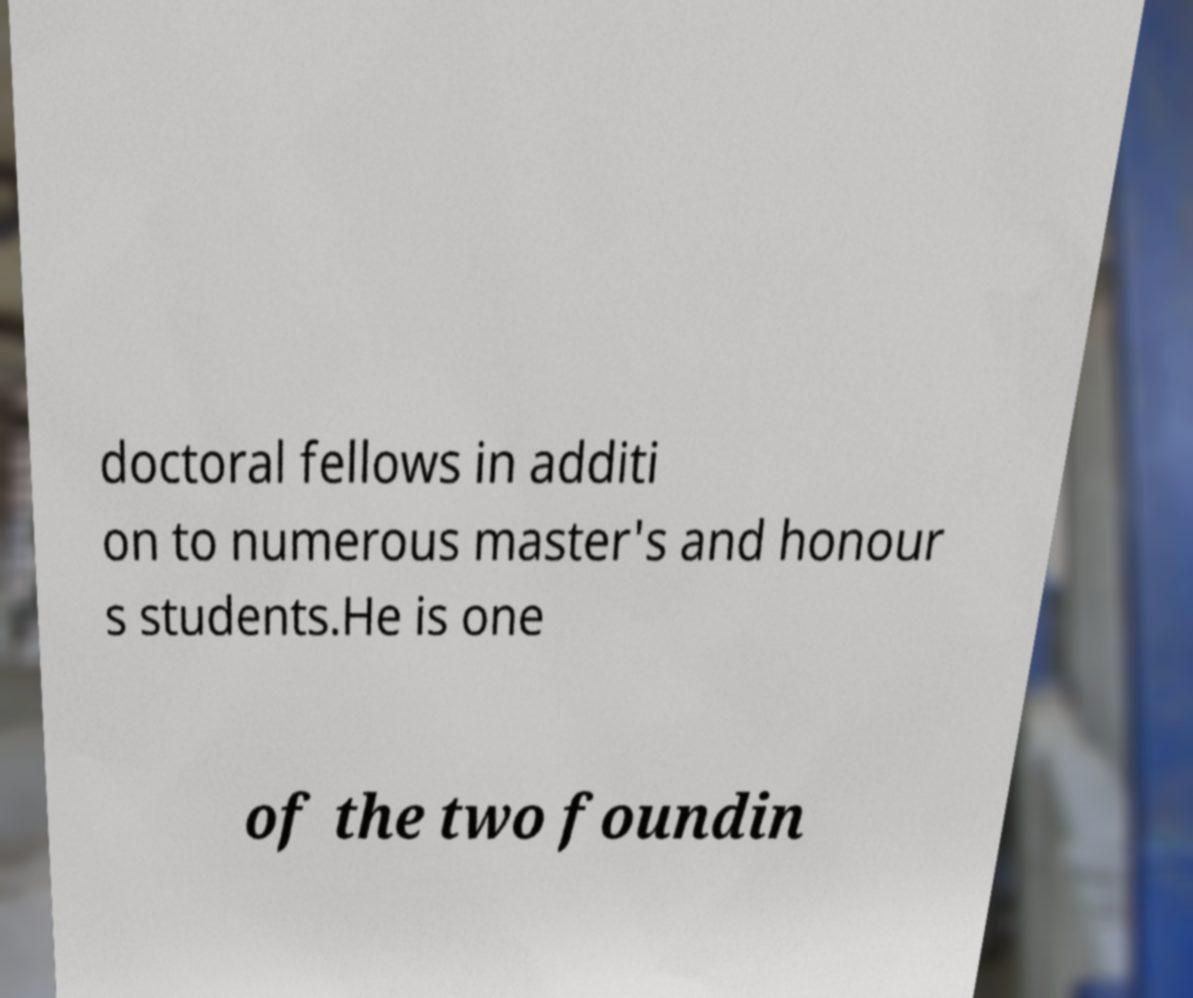For documentation purposes, I need the text within this image transcribed. Could you provide that? doctoral fellows in additi on to numerous master's and honour s students.He is one of the two foundin 